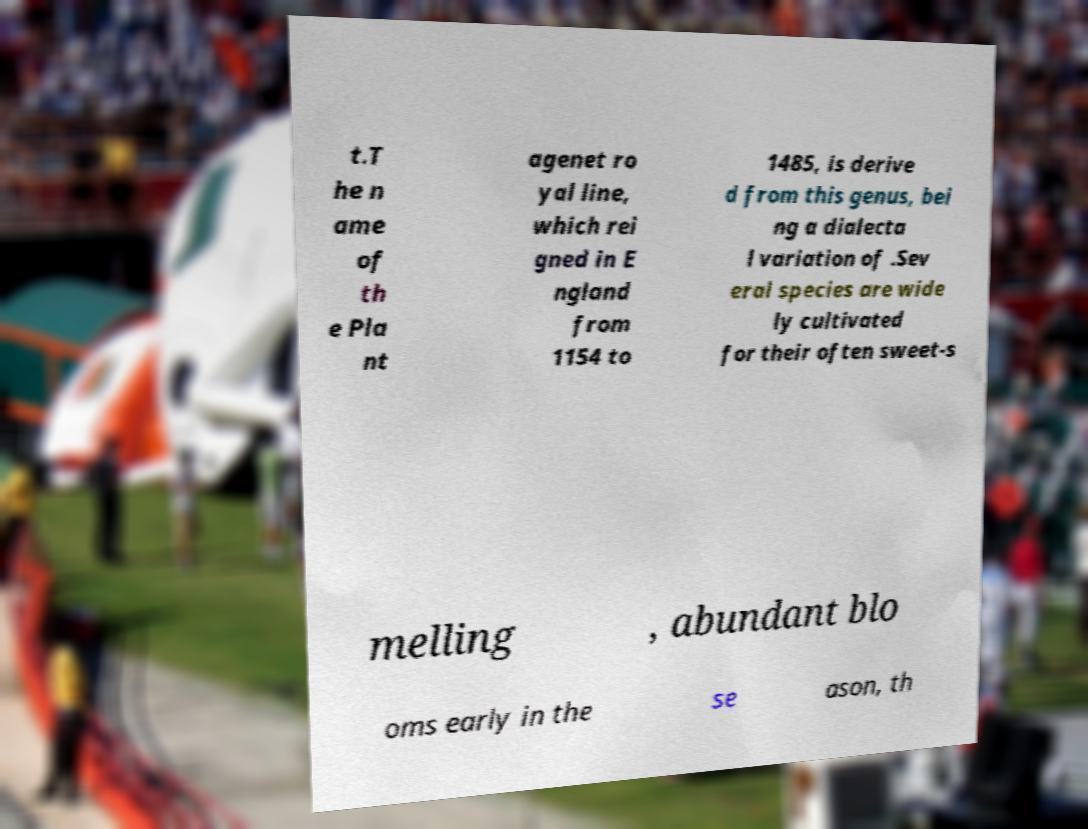Please identify and transcribe the text found in this image. t.T he n ame of th e Pla nt agenet ro yal line, which rei gned in E ngland from 1154 to 1485, is derive d from this genus, bei ng a dialecta l variation of .Sev eral species are wide ly cultivated for their often sweet-s melling , abundant blo oms early in the se ason, th 